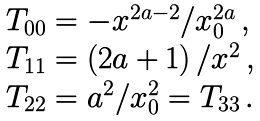<formula> <loc_0><loc_0><loc_500><loc_500>\begin{array} { l } T _ { 0 0 } = - x ^ { 2 a - 2 } / x _ { 0 } ^ { 2 a } \, , \\ T _ { 1 1 } = \left ( 2 a + 1 \right ) / x ^ { 2 } \, , \\ T _ { 2 2 } = a ^ { 2 } / x _ { 0 } ^ { 2 } = T _ { 3 3 } \, . \end{array}</formula> 